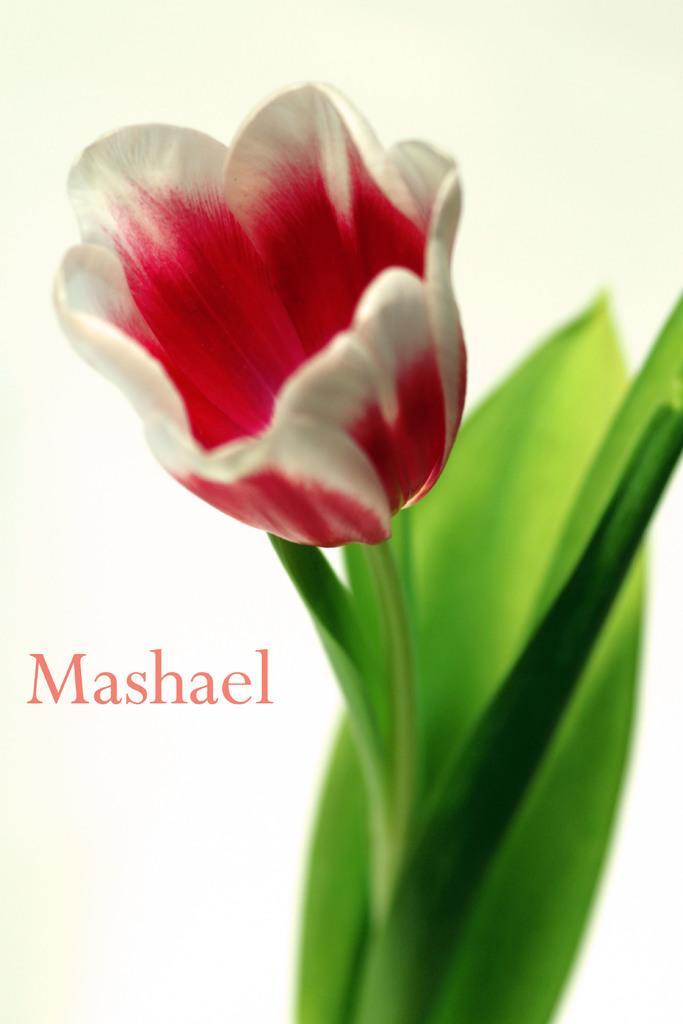What type of plant can be seen in the image? There is a flower in the image. What else is present on the plant besides the flower? There are leaves in the image. Where is the text located in the image? The text is on the left side of the image. What type of coach can be seen in the image? There is no coach present in the image. How many times does the text need to be folded to fit into the flower? The image does not show any folding or interaction between the text and the flower, so it is not possible to answer this question. 